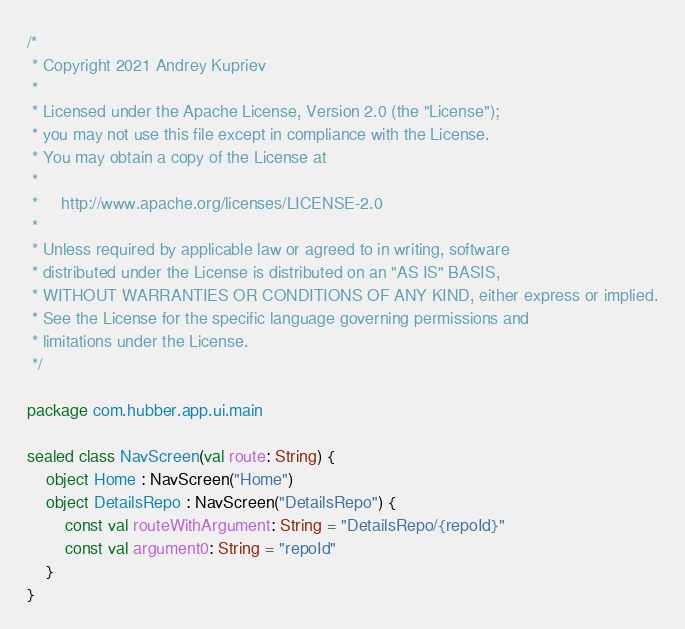Convert code to text. <code><loc_0><loc_0><loc_500><loc_500><_Kotlin_>/*
 * Copyright 2021 Andrey Kupriev
 *
 * Licensed under the Apache License, Version 2.0 (the "License");
 * you may not use this file except in compliance with the License.
 * You may obtain a copy of the License at
 *
 *     http://www.apache.org/licenses/LICENSE-2.0
 *
 * Unless required by applicable law or agreed to in writing, software
 * distributed under the License is distributed on an "AS IS" BASIS,
 * WITHOUT WARRANTIES OR CONDITIONS OF ANY KIND, either express or implied.
 * See the License for the specific language governing permissions and
 * limitations under the License.
 */
 
package com.hubber.app.ui.main

sealed class NavScreen(val route: String) {
    object Home : NavScreen("Home")
    object DetailsRepo : NavScreen("DetailsRepo") {
        const val routeWithArgument: String = "DetailsRepo/{repoId}"
        const val argument0: String = "repoId"
    }
}</code> 